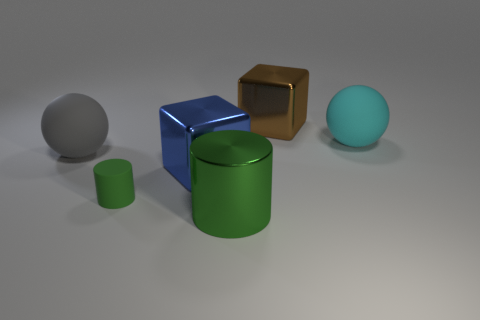Are there any other things that have the same material as the large blue thing?
Provide a succinct answer. Yes. Are there any large brown balls that have the same material as the big gray sphere?
Offer a very short reply. No. What material is the blue object that is the same size as the brown metallic block?
Offer a very short reply. Metal. How many other matte things have the same shape as the large cyan rubber thing?
Your answer should be very brief. 1. There is a green cylinder that is made of the same material as the big blue block; what is its size?
Give a very brief answer. Large. There is a large object that is both to the left of the metallic cylinder and on the right side of the tiny green object; what material is it made of?
Give a very brief answer. Metal. What number of green metallic cylinders have the same size as the cyan sphere?
Your response must be concise. 1. There is a large green object that is the same shape as the tiny matte thing; what material is it?
Offer a terse response. Metal. How many objects are big metallic blocks that are to the right of the blue shiny block or rubber things that are behind the big blue metallic block?
Offer a very short reply. 3. There is a tiny green matte object; is its shape the same as the large metal object left of the shiny cylinder?
Provide a short and direct response. No. 